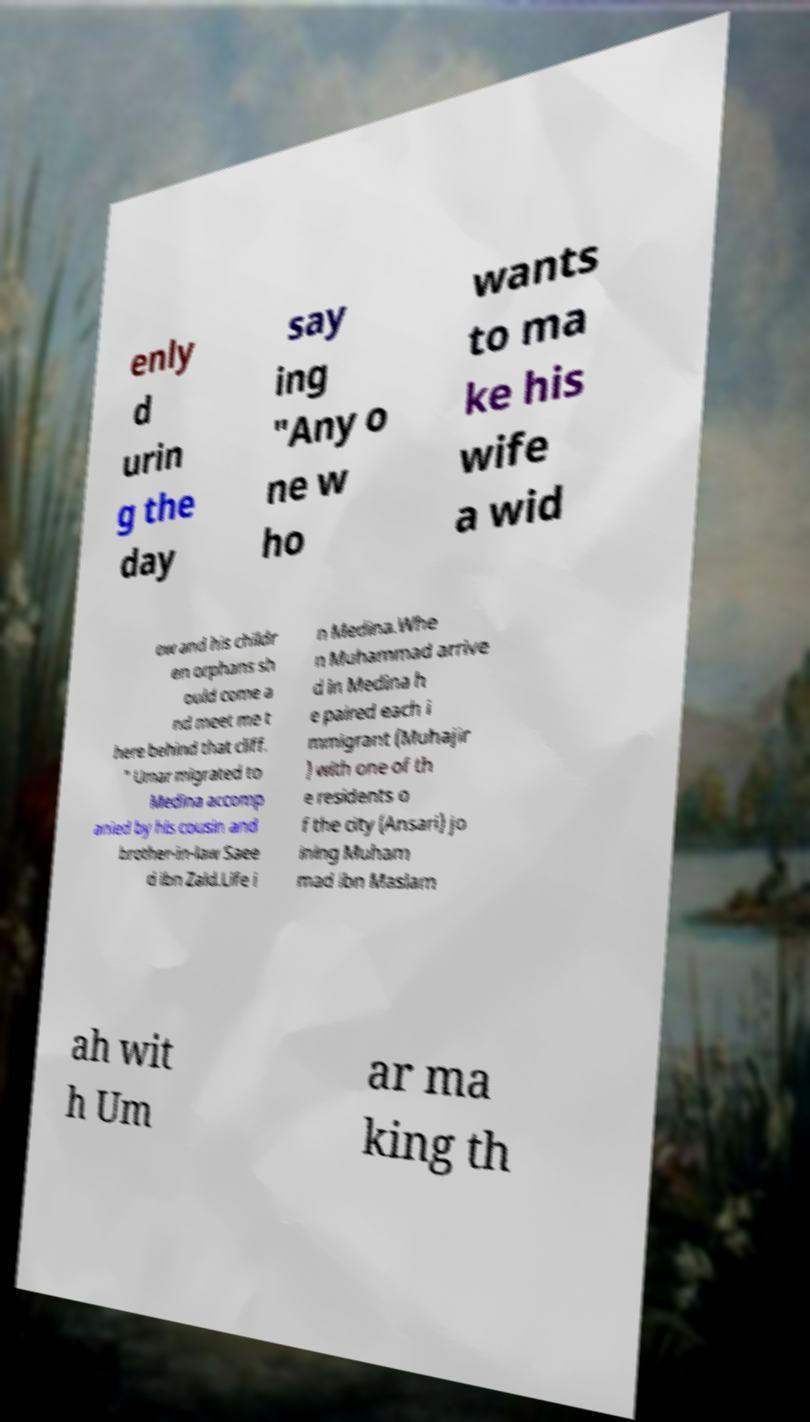What messages or text are displayed in this image? I need them in a readable, typed format. enly d urin g the day say ing "Any o ne w ho wants to ma ke his wife a wid ow and his childr en orphans sh ould come a nd meet me t here behind that cliff. " Umar migrated to Medina accomp anied by his cousin and brother-in-law Saee d ibn Zaid.Life i n Medina.Whe n Muhammad arrive d in Medina h e paired each i mmigrant (Muhajir ) with one of th e residents o f the city (Ansari) jo ining Muham mad ibn Maslam ah wit h Um ar ma king th 